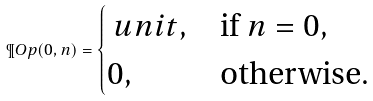Convert formula to latex. <formula><loc_0><loc_0><loc_500><loc_500>\P O p ( 0 , n ) = \begin{cases} \ u n i t , & \text {if $n = 0$} , \\ 0 , & \text {otherwise} . \end{cases}</formula> 